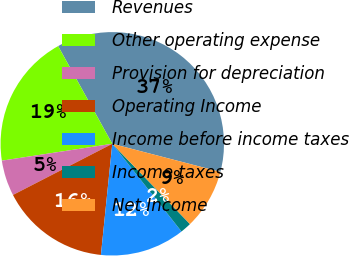<chart> <loc_0><loc_0><loc_500><loc_500><pie_chart><fcel>Revenues<fcel>Other operating expense<fcel>Provision for depreciation<fcel>Operating Income<fcel>Income before income taxes<fcel>Income taxes<fcel>Net Income<nl><fcel>37.11%<fcel>19.36%<fcel>5.16%<fcel>15.81%<fcel>12.26%<fcel>1.61%<fcel>8.71%<nl></chart> 